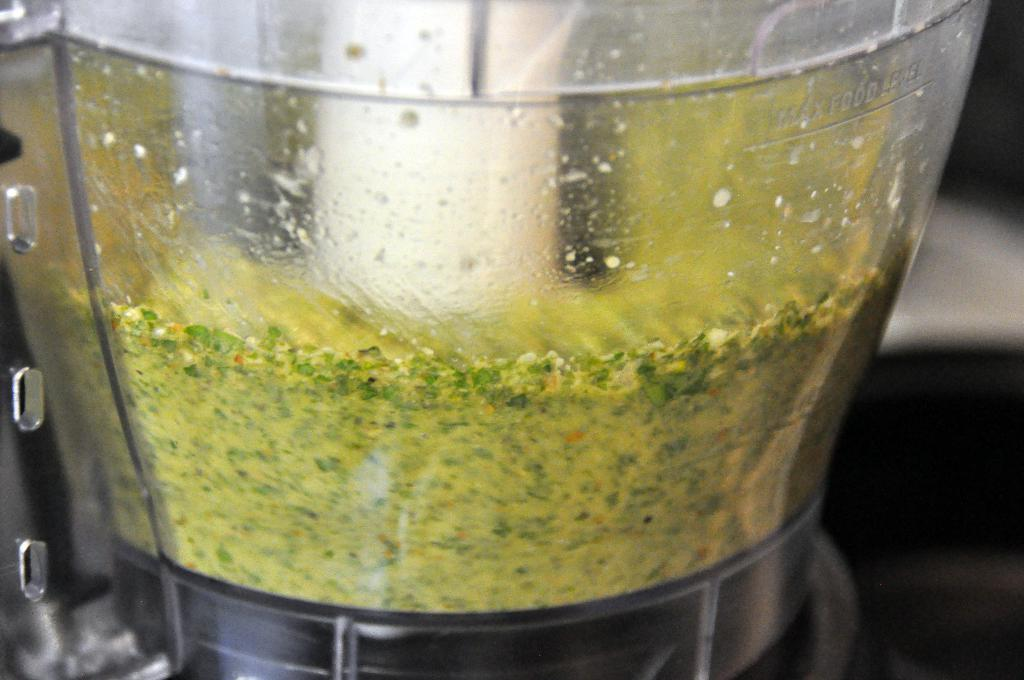What is located in the foreground of the image? There is a glass container in the foreground of the image. What is inside the glass container? The glass container contains food. How can the maximum food level be identified in the glass container? There is a maximum food level mark on the glass container. What type of throne is visible in the image? There is no throne present in the image. What color is the curtain behind the throne in the image? There is no curtain or throne present in the image. 